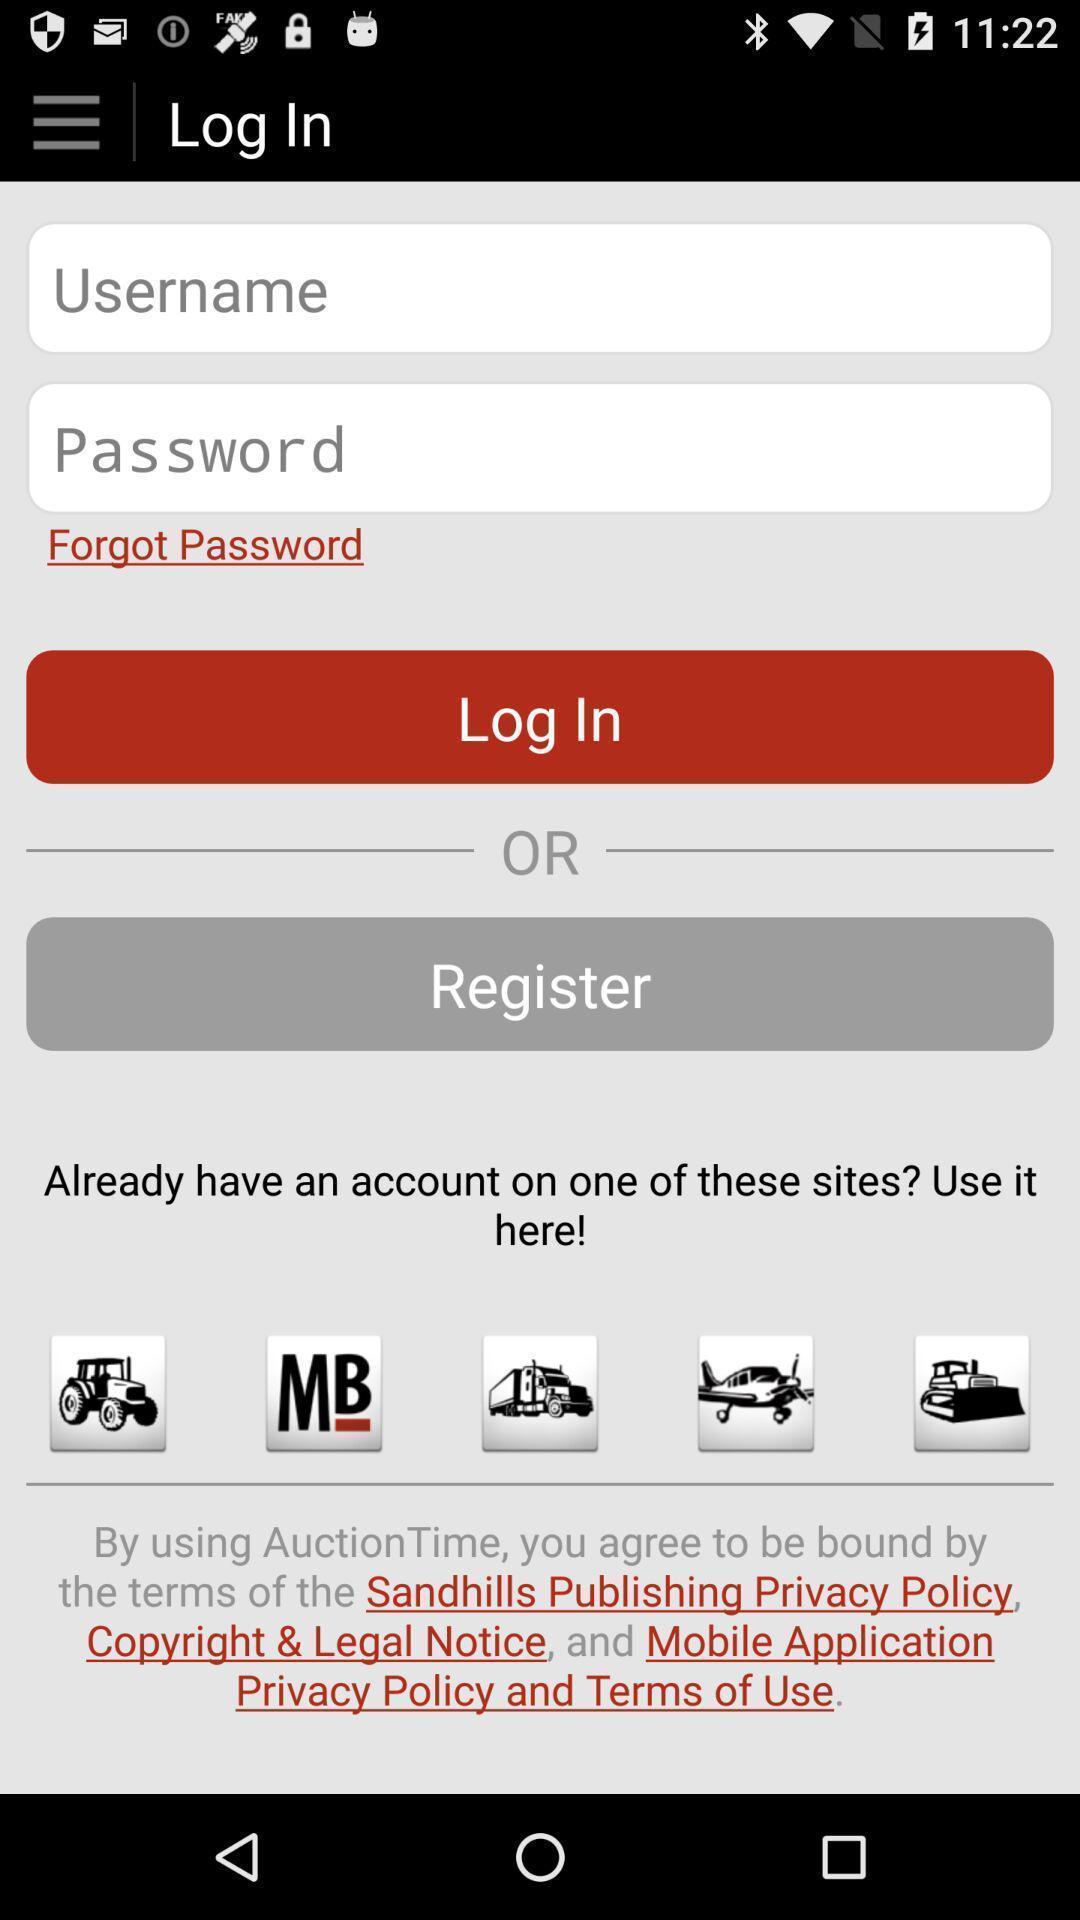Provide a description of this screenshot. Login page to enter user credential. 